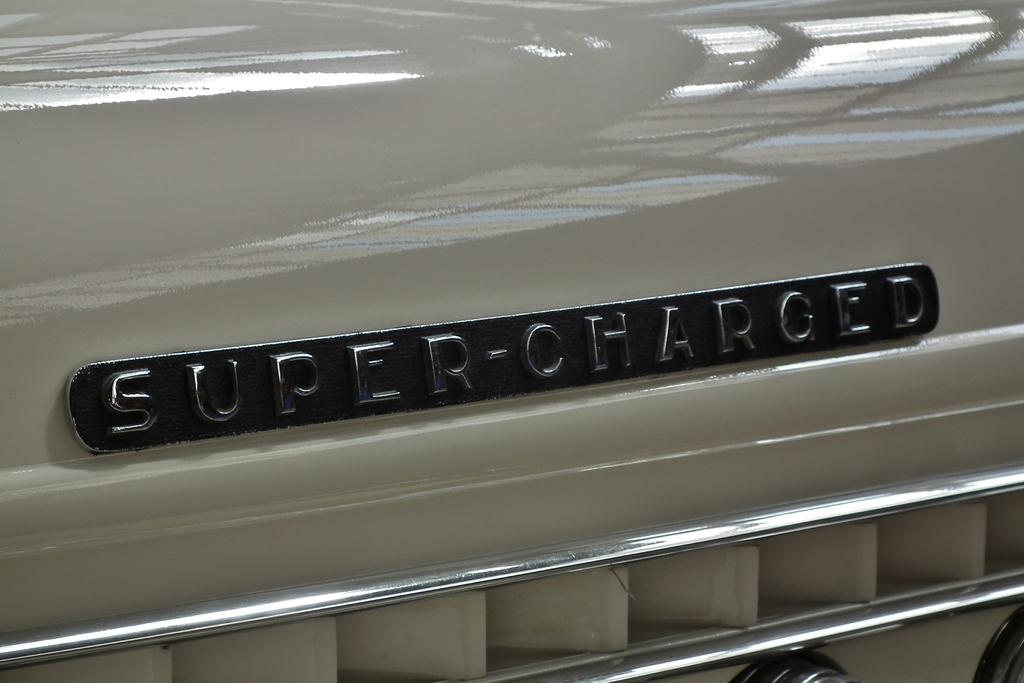What is the main object in the image? There is a name board in the image. What color is the name board? The name board is black in color. What type of surface is the name board attached to? The name board is on a metal surface. What type of stew is being prepared on the name board in the image? There is no stew or cooking activity present in the image; it only features a name board on a metal surface. 